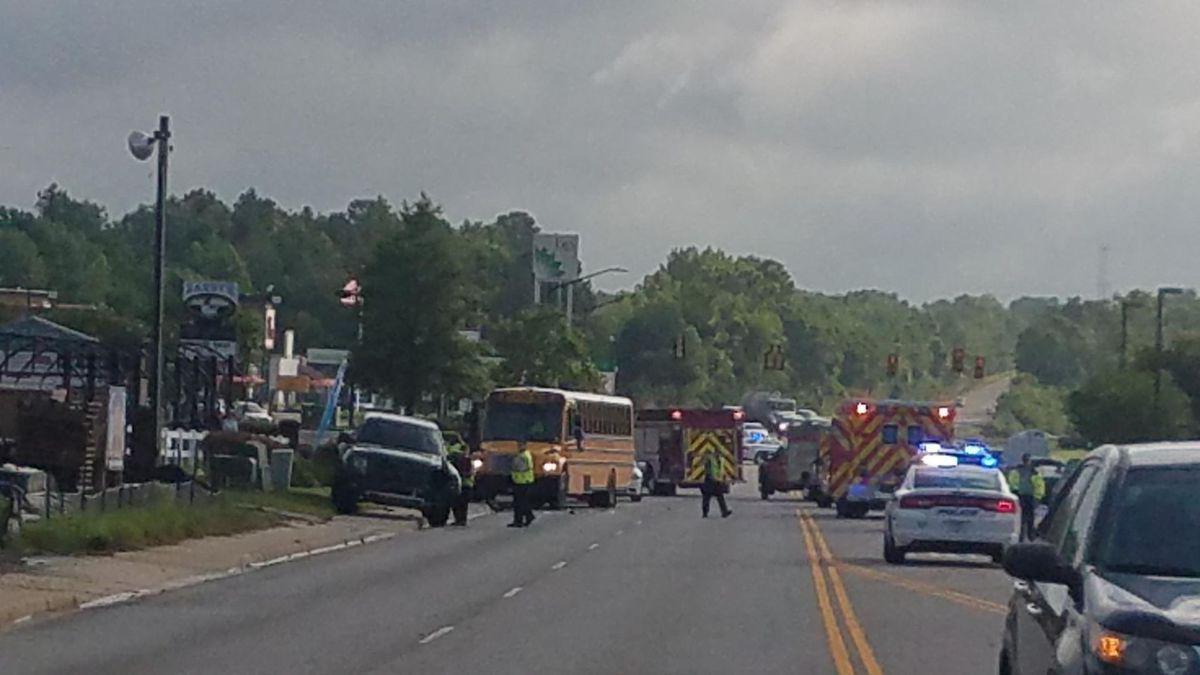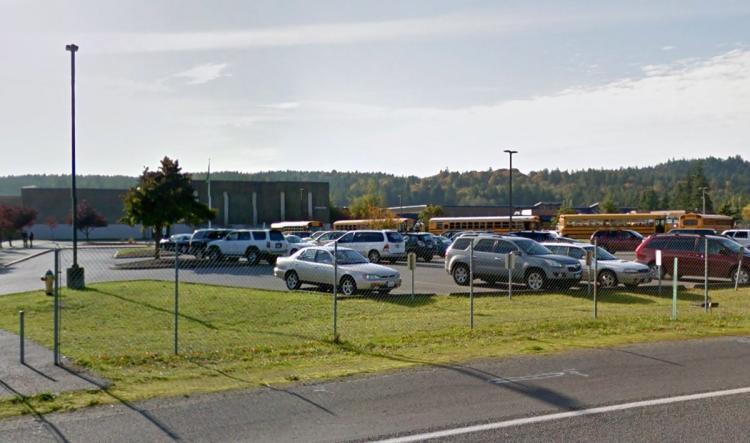The first image is the image on the left, the second image is the image on the right. Given the left and right images, does the statement "In at least one image there is one parked yellow bus near one police  vehicle." hold true? Answer yes or no. Yes. The first image is the image on the left, the second image is the image on the right. For the images shown, is this caption "Exactly one image contains both school buses and fire trucks." true? Answer yes or no. Yes. 